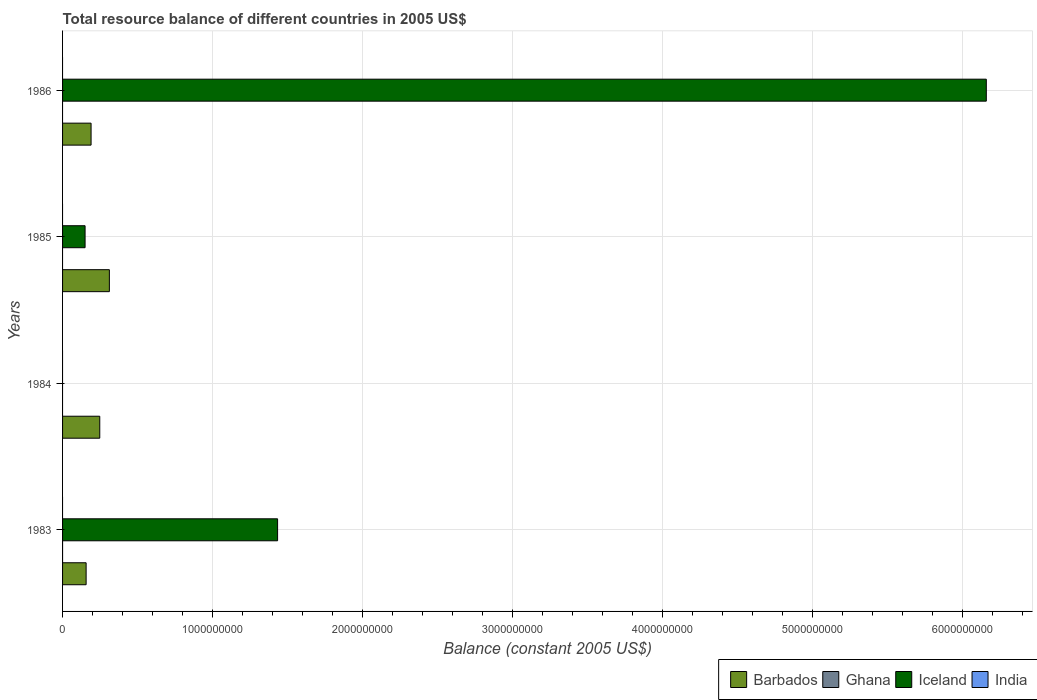How many different coloured bars are there?
Your answer should be compact. 2. Are the number of bars on each tick of the Y-axis equal?
Make the answer very short. No. How many bars are there on the 1st tick from the top?
Keep it short and to the point. 2. How many bars are there on the 1st tick from the bottom?
Keep it short and to the point. 2. What is the total resource balance in Iceland in 1983?
Give a very brief answer. 1.43e+09. Across all years, what is the maximum total resource balance in Iceland?
Your response must be concise. 6.16e+09. What is the total total resource balance in Barbados in the graph?
Keep it short and to the point. 9.07e+08. What is the difference between the total resource balance in Barbados in 1983 and that in 1985?
Give a very brief answer. -1.55e+08. What is the difference between the total resource balance in India in 1983 and the total resource balance in Barbados in 1984?
Make the answer very short. -2.48e+08. What is the average total resource balance in Iceland per year?
Keep it short and to the point. 1.94e+09. In the year 1983, what is the difference between the total resource balance in Barbados and total resource balance in Iceland?
Offer a very short reply. -1.28e+09. What is the ratio of the total resource balance in Iceland in 1983 to that in 1985?
Make the answer very short. 9.55. Is the difference between the total resource balance in Barbados in 1985 and 1986 greater than the difference between the total resource balance in Iceland in 1985 and 1986?
Give a very brief answer. Yes. What is the difference between the highest and the second highest total resource balance in Iceland?
Make the answer very short. 4.72e+09. What is the difference between the highest and the lowest total resource balance in Iceland?
Provide a succinct answer. 6.16e+09. In how many years, is the total resource balance in India greater than the average total resource balance in India taken over all years?
Offer a very short reply. 0. Is it the case that in every year, the sum of the total resource balance in Ghana and total resource balance in Barbados is greater than the sum of total resource balance in Iceland and total resource balance in India?
Keep it short and to the point. No. Is it the case that in every year, the sum of the total resource balance in Barbados and total resource balance in Iceland is greater than the total resource balance in Ghana?
Your answer should be compact. Yes. How many bars are there?
Ensure brevity in your answer.  7. Are all the bars in the graph horizontal?
Make the answer very short. Yes. What is the difference between two consecutive major ticks on the X-axis?
Ensure brevity in your answer.  1.00e+09. Where does the legend appear in the graph?
Ensure brevity in your answer.  Bottom right. What is the title of the graph?
Keep it short and to the point. Total resource balance of different countries in 2005 US$. What is the label or title of the X-axis?
Make the answer very short. Balance (constant 2005 US$). What is the Balance (constant 2005 US$) of Barbados in 1983?
Offer a terse response. 1.57e+08. What is the Balance (constant 2005 US$) in Iceland in 1983?
Offer a terse response. 1.43e+09. What is the Balance (constant 2005 US$) of Barbados in 1984?
Make the answer very short. 2.48e+08. What is the Balance (constant 2005 US$) in Ghana in 1984?
Your answer should be very brief. 0. What is the Balance (constant 2005 US$) in Barbados in 1985?
Provide a succinct answer. 3.12e+08. What is the Balance (constant 2005 US$) of Ghana in 1985?
Your response must be concise. 0. What is the Balance (constant 2005 US$) in Iceland in 1985?
Ensure brevity in your answer.  1.50e+08. What is the Balance (constant 2005 US$) in Barbados in 1986?
Provide a succinct answer. 1.90e+08. What is the Balance (constant 2005 US$) in Ghana in 1986?
Make the answer very short. 0. What is the Balance (constant 2005 US$) in Iceland in 1986?
Offer a terse response. 6.16e+09. Across all years, what is the maximum Balance (constant 2005 US$) in Barbados?
Make the answer very short. 3.12e+08. Across all years, what is the maximum Balance (constant 2005 US$) in Iceland?
Offer a terse response. 6.16e+09. Across all years, what is the minimum Balance (constant 2005 US$) in Barbados?
Make the answer very short. 1.57e+08. What is the total Balance (constant 2005 US$) in Barbados in the graph?
Provide a succinct answer. 9.07e+08. What is the total Balance (constant 2005 US$) in Ghana in the graph?
Offer a terse response. 0. What is the total Balance (constant 2005 US$) in Iceland in the graph?
Give a very brief answer. 7.74e+09. What is the total Balance (constant 2005 US$) in India in the graph?
Ensure brevity in your answer.  0. What is the difference between the Balance (constant 2005 US$) in Barbados in 1983 and that in 1984?
Your answer should be very brief. -9.10e+07. What is the difference between the Balance (constant 2005 US$) of Barbados in 1983 and that in 1985?
Your answer should be compact. -1.55e+08. What is the difference between the Balance (constant 2005 US$) of Iceland in 1983 and that in 1985?
Provide a succinct answer. 1.28e+09. What is the difference between the Balance (constant 2005 US$) of Barbados in 1983 and that in 1986?
Provide a succinct answer. -3.30e+07. What is the difference between the Balance (constant 2005 US$) of Iceland in 1983 and that in 1986?
Your response must be concise. -4.72e+09. What is the difference between the Balance (constant 2005 US$) in Barbados in 1984 and that in 1985?
Make the answer very short. -6.40e+07. What is the difference between the Balance (constant 2005 US$) of Barbados in 1984 and that in 1986?
Your answer should be very brief. 5.80e+07. What is the difference between the Balance (constant 2005 US$) in Barbados in 1985 and that in 1986?
Provide a short and direct response. 1.22e+08. What is the difference between the Balance (constant 2005 US$) in Iceland in 1985 and that in 1986?
Give a very brief answer. -6.01e+09. What is the difference between the Balance (constant 2005 US$) in Barbados in 1983 and the Balance (constant 2005 US$) in Iceland in 1985?
Give a very brief answer. 6.90e+06. What is the difference between the Balance (constant 2005 US$) of Barbados in 1983 and the Balance (constant 2005 US$) of Iceland in 1986?
Give a very brief answer. -6.00e+09. What is the difference between the Balance (constant 2005 US$) in Barbados in 1984 and the Balance (constant 2005 US$) in Iceland in 1985?
Keep it short and to the point. 9.79e+07. What is the difference between the Balance (constant 2005 US$) in Barbados in 1984 and the Balance (constant 2005 US$) in Iceland in 1986?
Make the answer very short. -5.91e+09. What is the difference between the Balance (constant 2005 US$) of Barbados in 1985 and the Balance (constant 2005 US$) of Iceland in 1986?
Your response must be concise. -5.85e+09. What is the average Balance (constant 2005 US$) in Barbados per year?
Your answer should be very brief. 2.27e+08. What is the average Balance (constant 2005 US$) in Iceland per year?
Ensure brevity in your answer.  1.94e+09. In the year 1983, what is the difference between the Balance (constant 2005 US$) of Barbados and Balance (constant 2005 US$) of Iceland?
Your answer should be very brief. -1.28e+09. In the year 1985, what is the difference between the Balance (constant 2005 US$) of Barbados and Balance (constant 2005 US$) of Iceland?
Ensure brevity in your answer.  1.62e+08. In the year 1986, what is the difference between the Balance (constant 2005 US$) of Barbados and Balance (constant 2005 US$) of Iceland?
Your response must be concise. -5.97e+09. What is the ratio of the Balance (constant 2005 US$) in Barbados in 1983 to that in 1984?
Offer a very short reply. 0.63. What is the ratio of the Balance (constant 2005 US$) of Barbados in 1983 to that in 1985?
Offer a very short reply. 0.5. What is the ratio of the Balance (constant 2005 US$) in Iceland in 1983 to that in 1985?
Provide a short and direct response. 9.55. What is the ratio of the Balance (constant 2005 US$) of Barbados in 1983 to that in 1986?
Provide a short and direct response. 0.83. What is the ratio of the Balance (constant 2005 US$) of Iceland in 1983 to that in 1986?
Make the answer very short. 0.23. What is the ratio of the Balance (constant 2005 US$) of Barbados in 1984 to that in 1985?
Give a very brief answer. 0.79. What is the ratio of the Balance (constant 2005 US$) of Barbados in 1984 to that in 1986?
Keep it short and to the point. 1.31. What is the ratio of the Balance (constant 2005 US$) in Barbados in 1985 to that in 1986?
Provide a short and direct response. 1.64. What is the ratio of the Balance (constant 2005 US$) in Iceland in 1985 to that in 1986?
Make the answer very short. 0.02. What is the difference between the highest and the second highest Balance (constant 2005 US$) of Barbados?
Give a very brief answer. 6.40e+07. What is the difference between the highest and the second highest Balance (constant 2005 US$) in Iceland?
Make the answer very short. 4.72e+09. What is the difference between the highest and the lowest Balance (constant 2005 US$) of Barbados?
Offer a very short reply. 1.55e+08. What is the difference between the highest and the lowest Balance (constant 2005 US$) in Iceland?
Make the answer very short. 6.16e+09. 